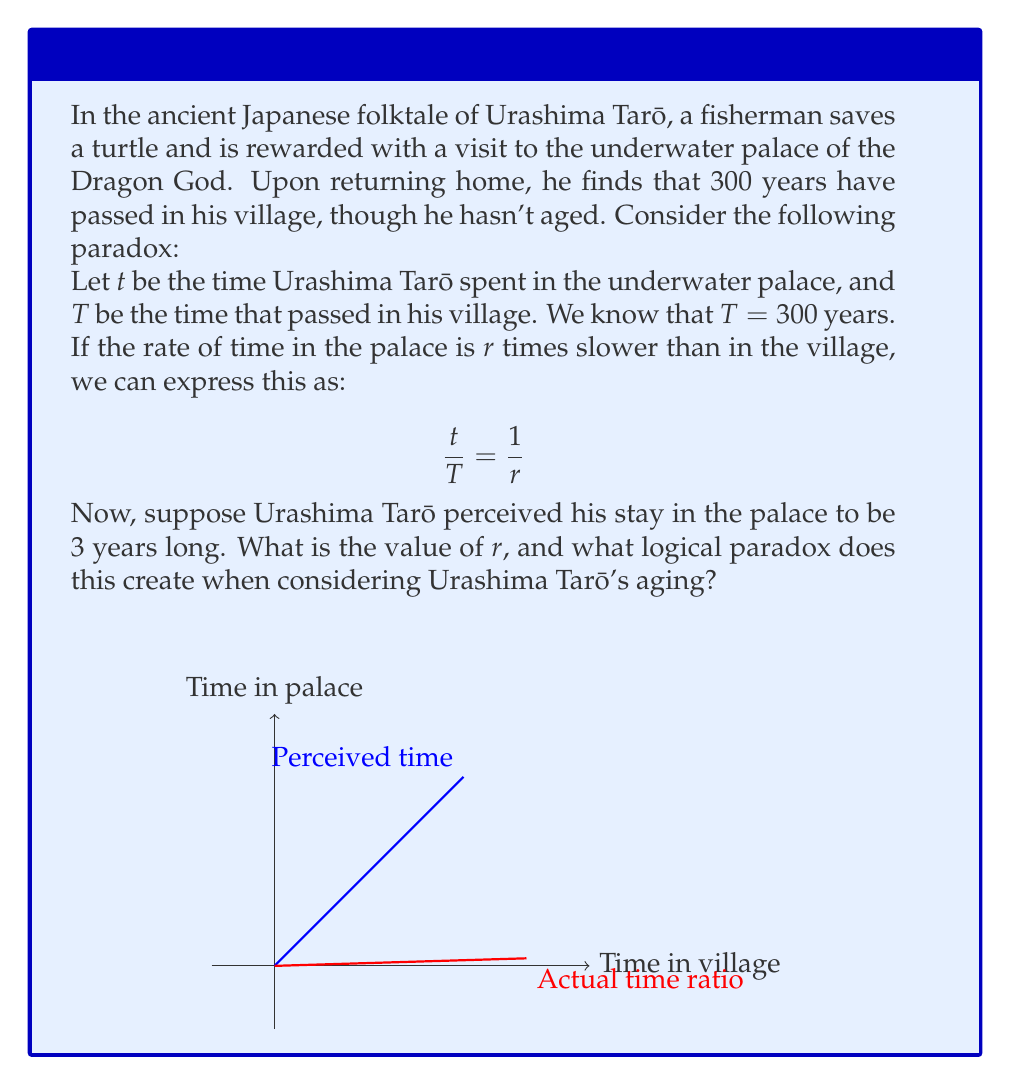Can you solve this math problem? Let's approach this step-by-step:

1) We know that $T = 300$ years and $t = 3$ years (as perceived by Urashima Tarō).

2) Using the equation $\frac{t}{T} = \frac{1}{r}$, we can substitute the known values:

   $$\frac{3}{300} = \frac{1}{r}$$

3) Simplifying:
   
   $$\frac{1}{100} = \frac{1}{r}$$

4) Therefore, $r = 100$. This means time in the palace passes 100 times slower than in the village.

5) The paradox arises when we consider Urashima Tarō's aging:
   - In the village, 300 years passed.
   - In the palace, Urashima Tarō experienced 3 years.
   - If time passed 100 times slower for him, his body should have aged by 3 years.
   - However, when he returned to the village, he hadn't aged at all.

6) This creates a logical paradox:
   - If time passed slower for him, he should have aged less than 3 years relative to the village, but not zero.
   - If he didn't age at all, it suggests time stopped for him completely, which contradicts his perception of 3 years passing.

This paradox highlights the complexities and inconsistencies often found in time travel and magical realms in folktales, challenging our logical understanding of time and aging.
Answer: $r = 100$; Paradox: No aging despite experiencing time passage 